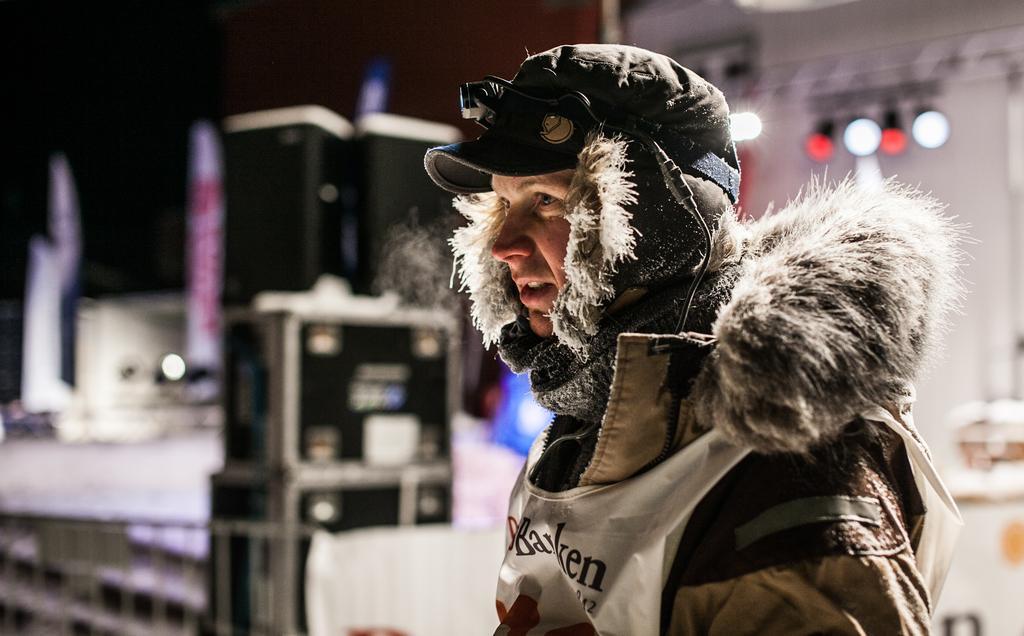In one or two sentences, can you explain what this image depicts? In this image, I can see a person with a cap and clothes. In the background, there are objects, which are looking blurred. 